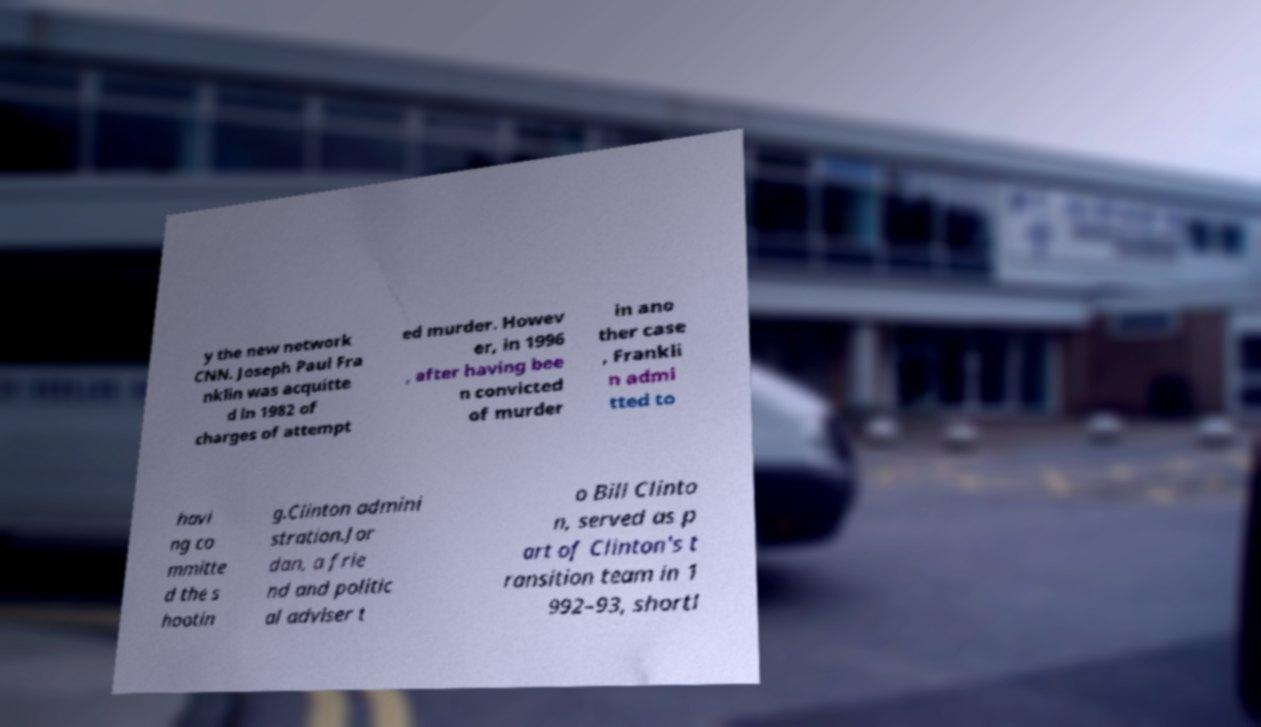Could you extract and type out the text from this image? y the new network CNN. Joseph Paul Fra nklin was acquitte d in 1982 of charges of attempt ed murder. Howev er, in 1996 , after having bee n convicted of murder in ano ther case , Frankli n admi tted to havi ng co mmitte d the s hootin g.Clinton admini stration.Jor dan, a frie nd and politic al adviser t o Bill Clinto n, served as p art of Clinton's t ransition team in 1 992–93, shortl 